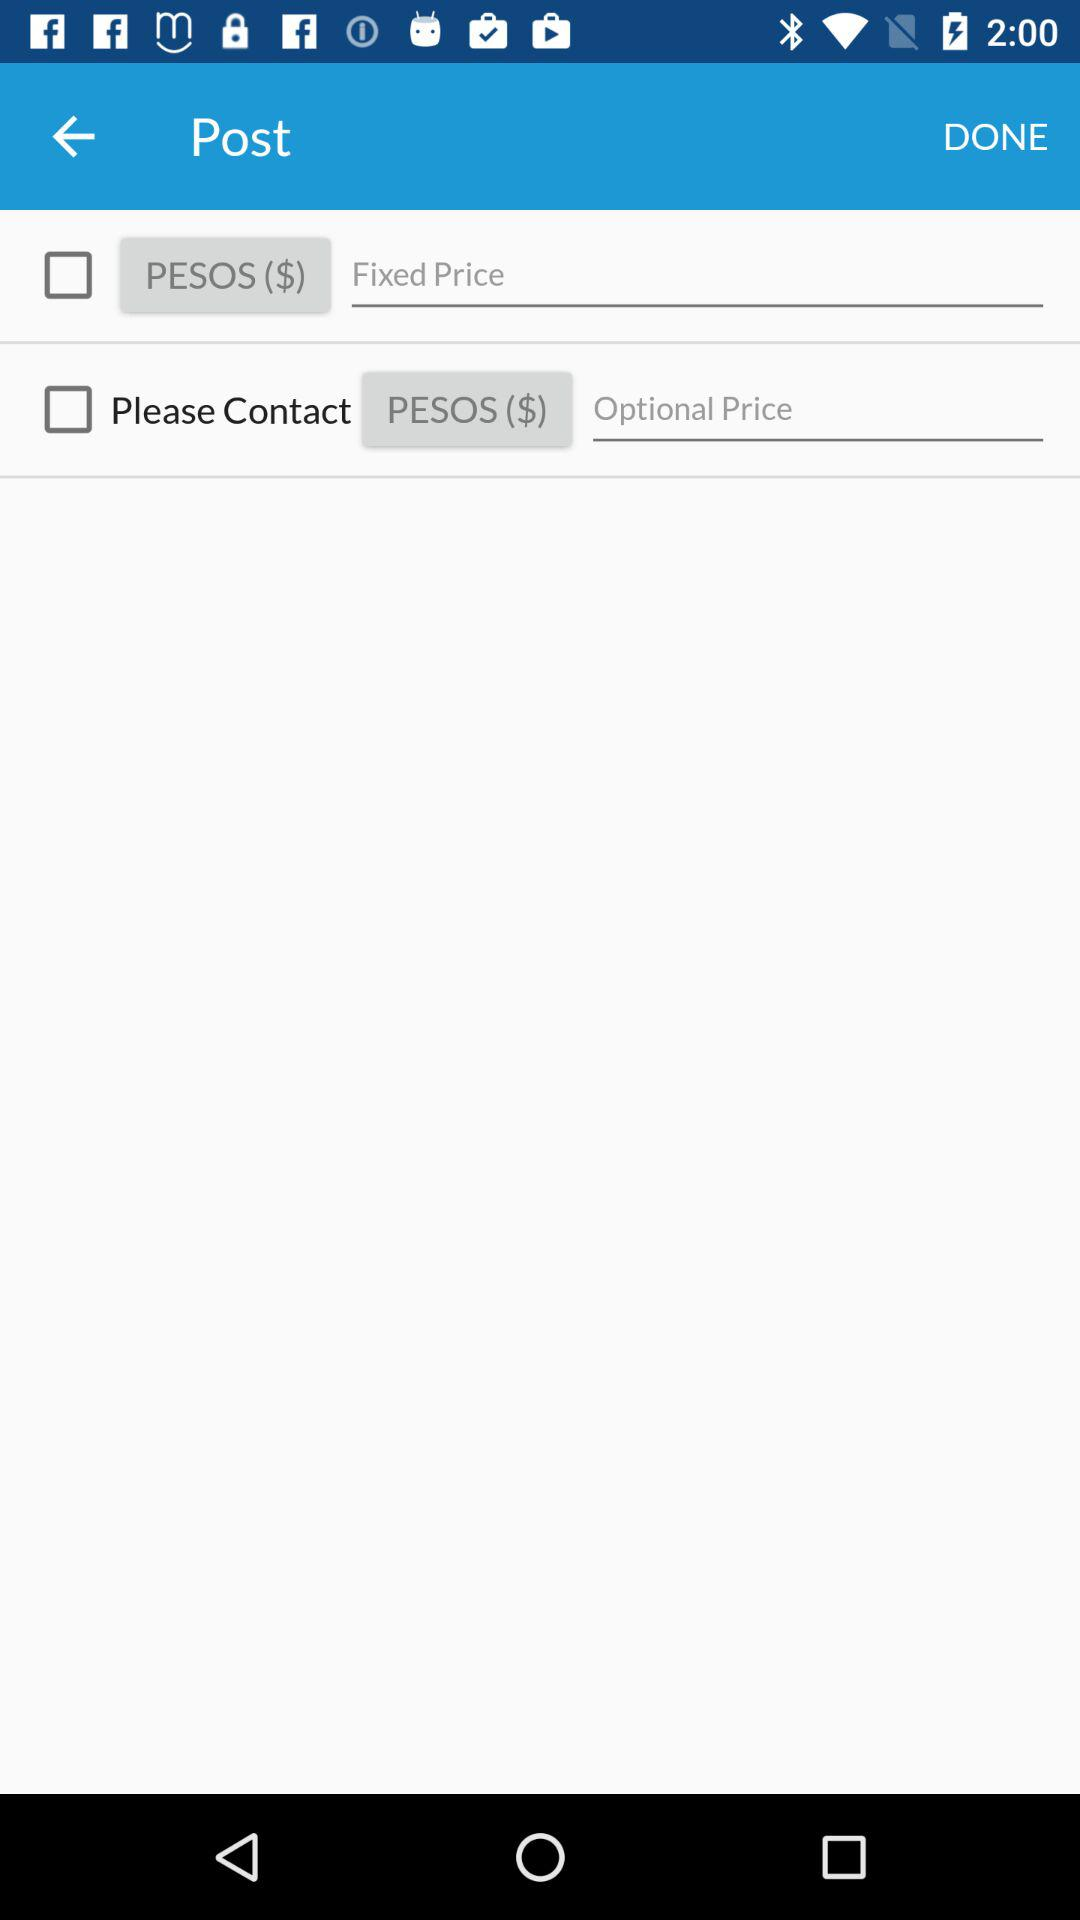What is the status of "Please Contact"? The status of "Please Contact" is "off". 